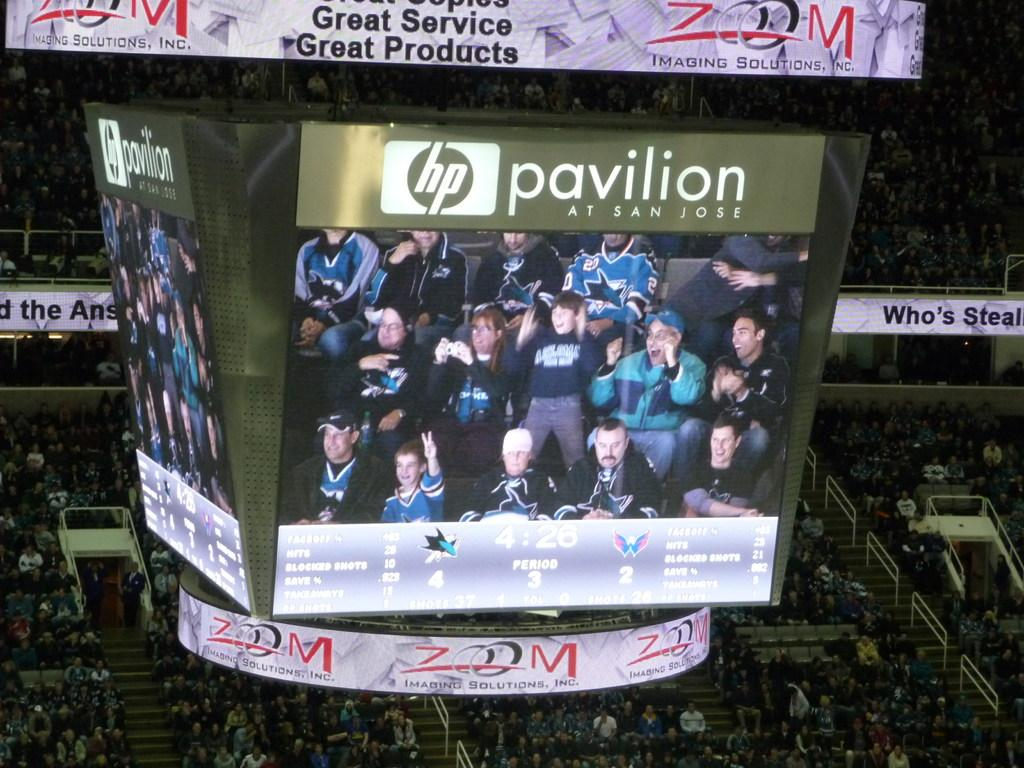<image>
Render a clear and concise summary of the photo. a scoreboard with the name Pavillion at the top of it 